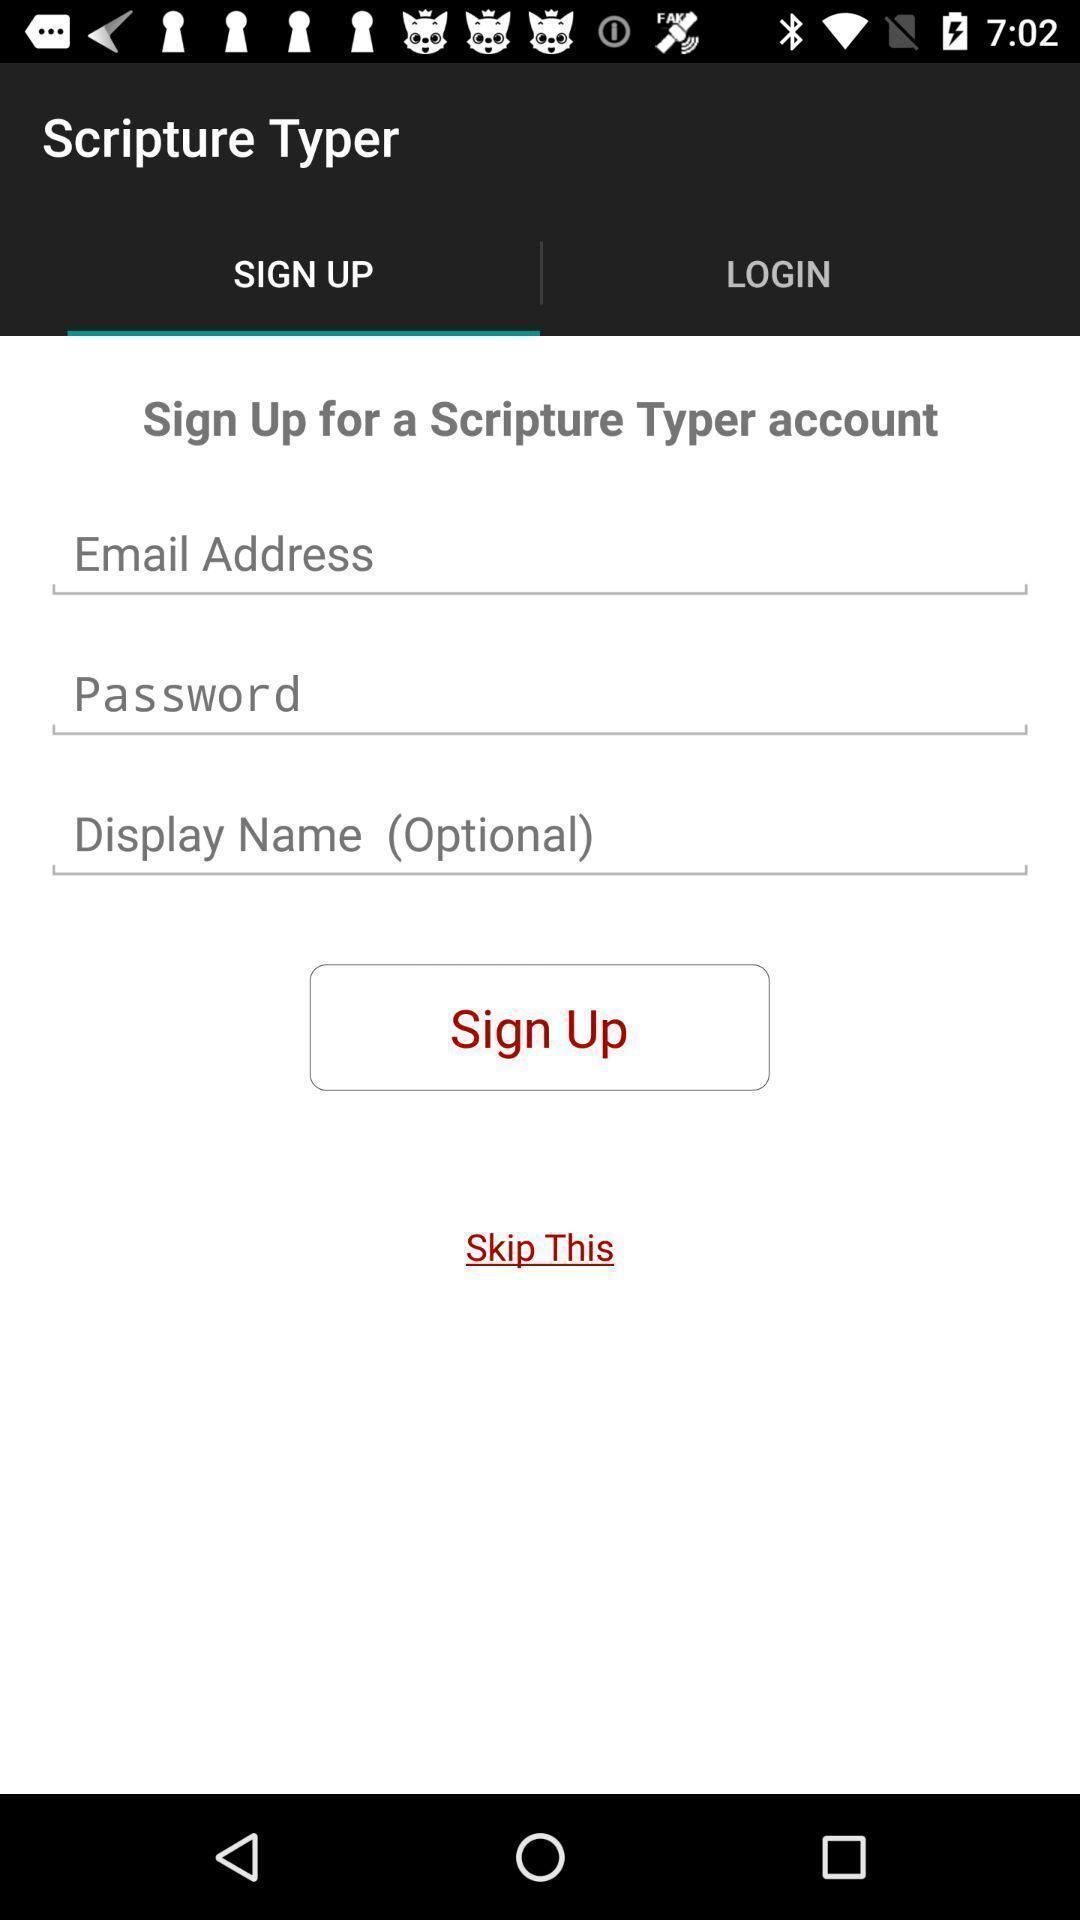Summarize the main components in this picture. Sign up page for the religious app. 